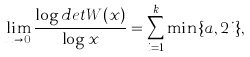Convert formula to latex. <formula><loc_0><loc_0><loc_500><loc_500>\lim _ { x \rightarrow 0 } \frac { \log d e t W ( x ) } { \log x } = \sum _ { i = 1 } ^ { k } \min \{ a , 2 i \} ,</formula> 